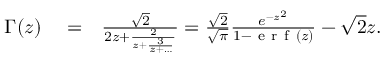<formula> <loc_0><loc_0><loc_500><loc_500>\begin{array} { r l r } { \Gamma ( z ) } & = } & { \frac { \sqrt { 2 } } { 2 z + \frac { 2 } { z + \frac { 3 } { z + \dots } } } = \frac { \sqrt { 2 } } { \sqrt { \pi } } \frac { e ^ { - z ^ { 2 } } } { 1 - e r f \left ( z \right ) } - \sqrt { 2 } z . } \end{array}</formula> 